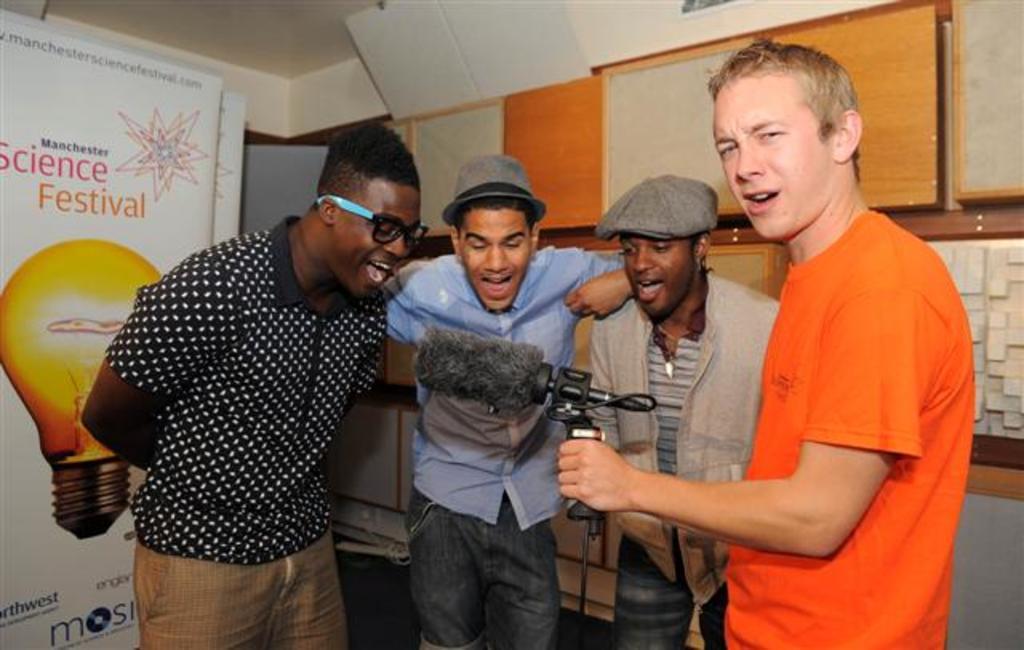Could you give a brief overview of what you see in this image? This picture shows a few people standing and we see a man a item in his hand and we see couple of them wore caps on their heads and we see a hoarding on the side. 